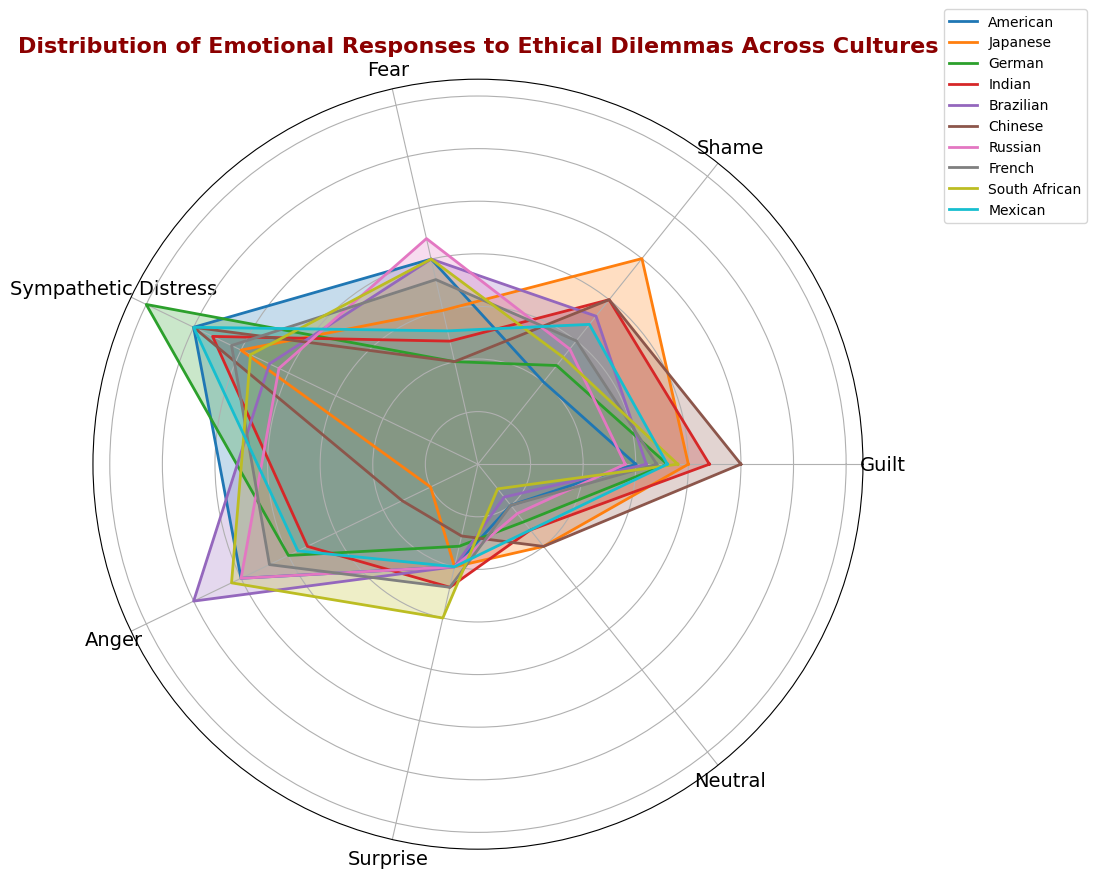Which culture exhibits the highest level of sympathetic distress? By observing the radar chart, we compare the points representing sympathetic distress for each culture. The culture with the point farthest from the center on this axis has the highest level of sympathetic distress.
Answer: German Which culture has the highest combined score of guilt and shame? We look at the data for guilt and shame for each culture and add these values together. The culture with the highest total is the answer. For example, American has 15 (guilt) + 10 (shame) = 25, and so on.
Answer: Japanese How does the average level of fear in South Africa compare to that in Russia? To find the average level of fear, we look at the values for fear in both countries and compare them directly. South Africa has 20 and Russia has 22. The average or arithmetic mean isn't necessary here, as it's a direct comparison.
Answer: Russia has a slightly higher level of fear than South Africa Which cultures display equal levels of surprise? By checking the radar chart, we identify any cultures that share the same values on the surprise axis.
Answer: American, Japanese, Brazilian, Russian, and Mexican What is the difference in anger levels between Americans and Brazilians? Look at the anger value for Americans (25) and Brazilians (30), and calculate the difference. 30 - 25 = 5.
Answer: 5 Which culture shows the lowest level of neutral emotional response, and what is the value? Identify the smallest value plotted on the neutral axis for all the cultures, and read its corresponding value.
Answer: South African, 3 Which culture's emotional response exhibits the greatest variation across all categories? Evaluate the extent of the spread of the polygon for each culture. The culture with the widest range between its highest and lowest points demonstrates the greatest variation.
Answer: Chinese Based on the chart, which cultural group stands out as having a balanced representation across all emotions? Observe the symmetry and uniformity of the shapes formed in the radar chart. The culture whose polygon appears most circular and balanced across all axes has the most balanced distribution.
Answer: French Can you infer which two emotions are most prevalent in the Indian culture? By visually inspecting the radar chart for India, identify the two vertices of the polygon which are the furthest from the center.
Answer: Guilt and Sympathetic Distress How many cultures exhibit a guilt response greater than 20? Count the number of cultures with guilt values above 20 by looking at the radar chart.
Answer: 3 